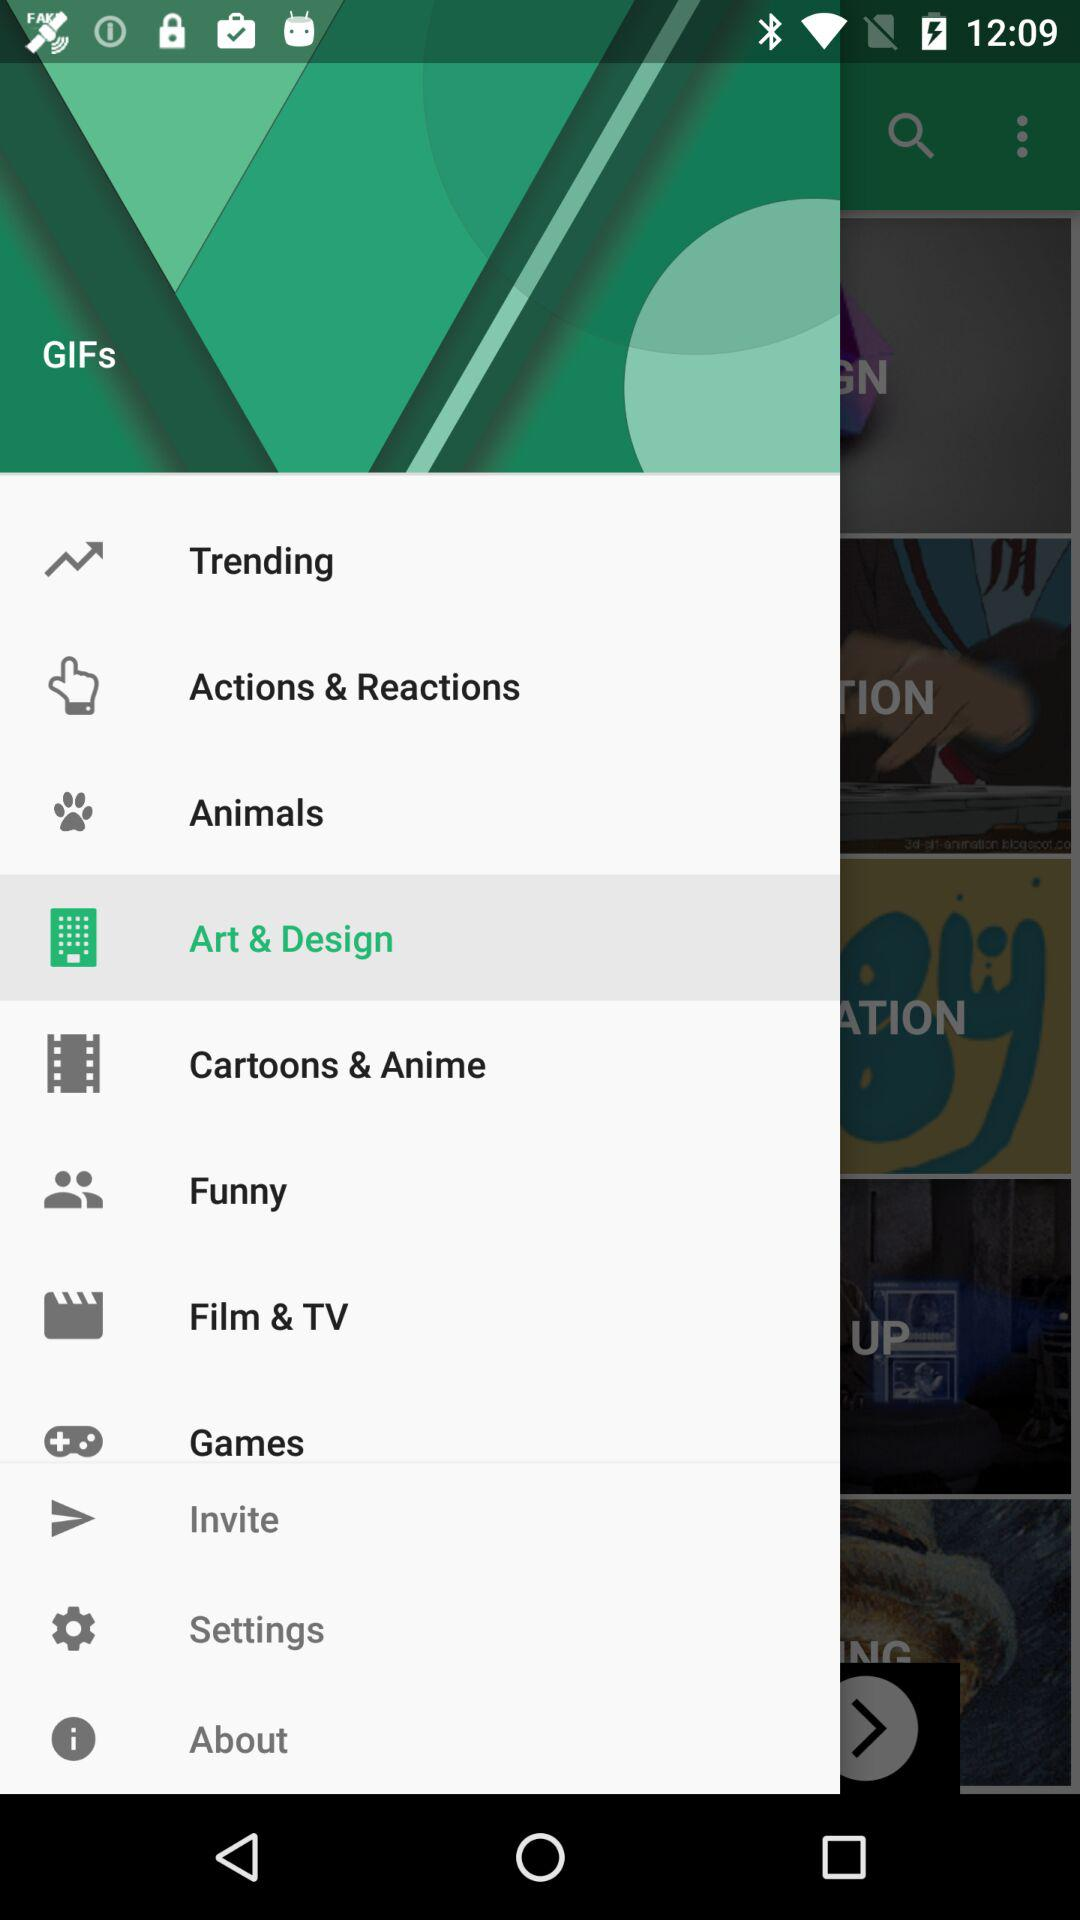Which option has been selected? The selected option is "Art & Design". 